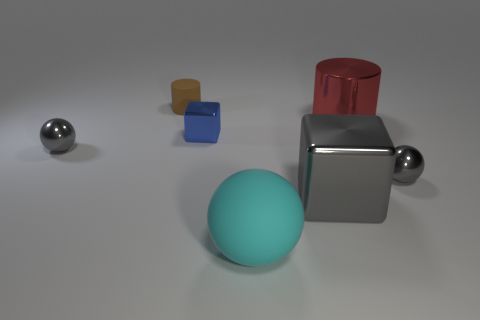The cyan sphere that is made of the same material as the brown object is what size?
Your response must be concise. Large. Is the small cylinder the same color as the big metal cylinder?
Give a very brief answer. No. There is a tiny gray metal object that is to the right of the large cyan matte object; is it the same shape as the blue shiny thing?
Offer a very short reply. No. What number of purple balls have the same size as the shiny cylinder?
Make the answer very short. 0. There is a gray sphere to the right of the big cyan thing; are there any big metallic objects behind it?
Give a very brief answer. Yes. What number of objects are either tiny gray shiny objects to the left of the tiny matte cylinder or gray shiny spheres?
Your answer should be compact. 2. What number of large metal objects are there?
Offer a terse response. 2. There is a large object that is made of the same material as the tiny brown cylinder; what is its shape?
Your answer should be compact. Sphere. What size is the shiny ball in front of the small gray metal sphere that is left of the big cylinder?
Make the answer very short. Small. How many things are either tiny things on the left side of the big metallic block or cylinders that are to the right of the tiny blue metallic thing?
Your answer should be compact. 4. 